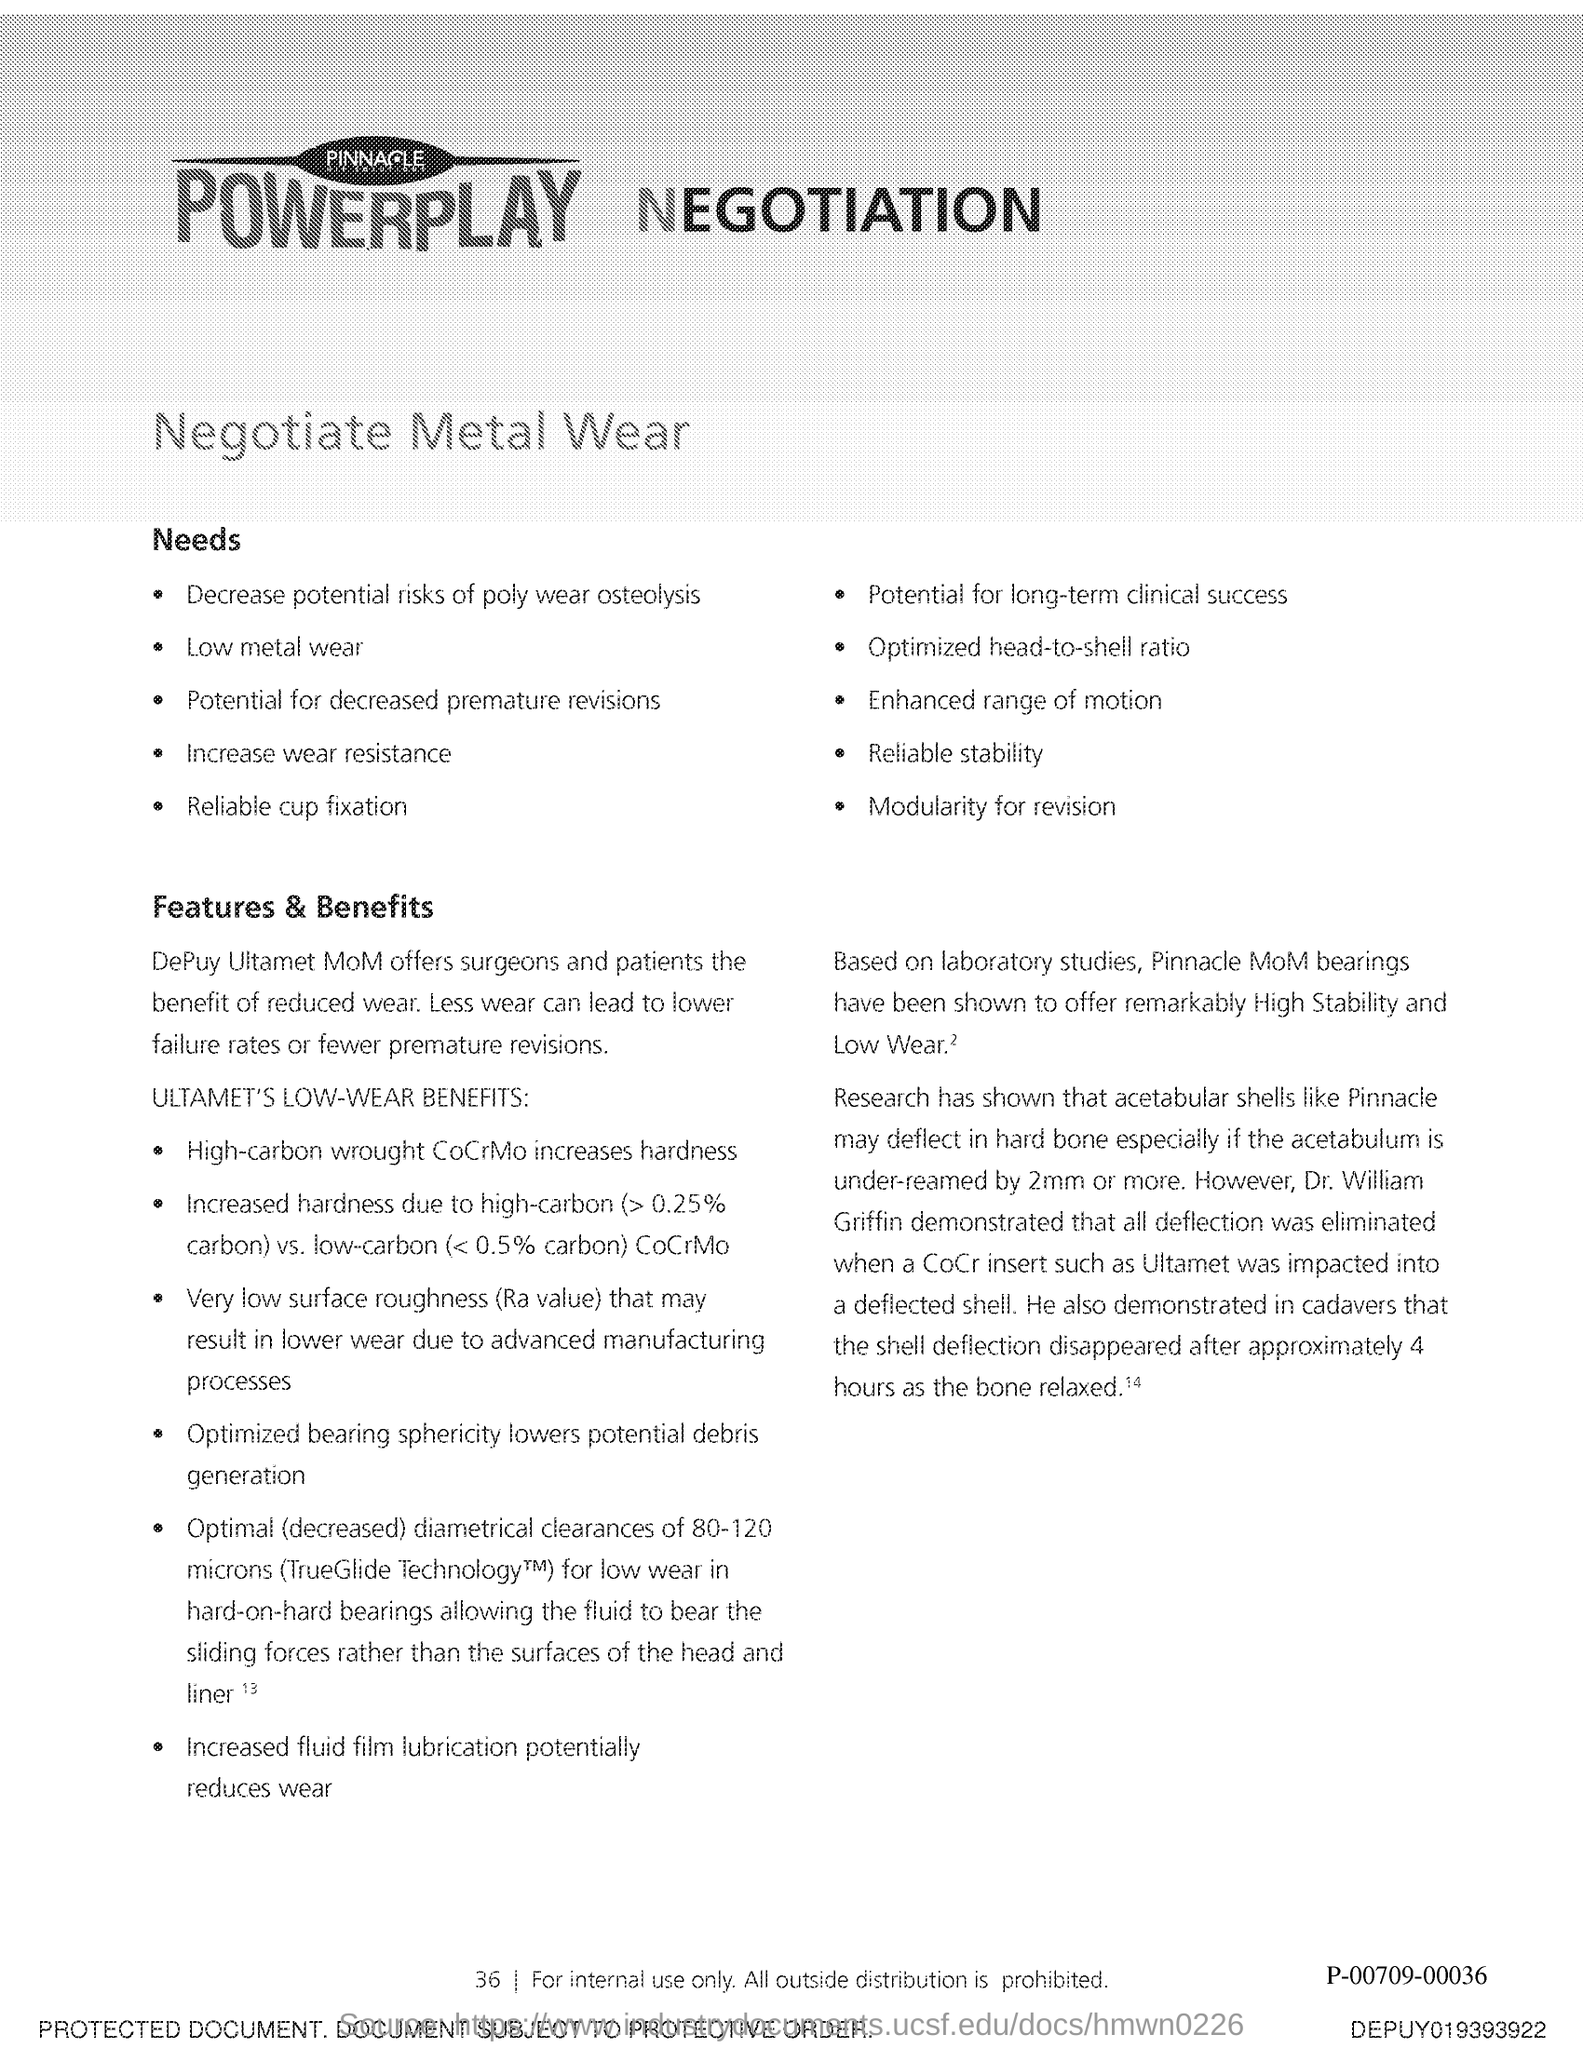What offers surgeons and patients the benefit of reduced wear?
Offer a terse response. DePuy Ultamet MoM. What potentially reduces wear?
Make the answer very short. Increased fluid film lubrication. 